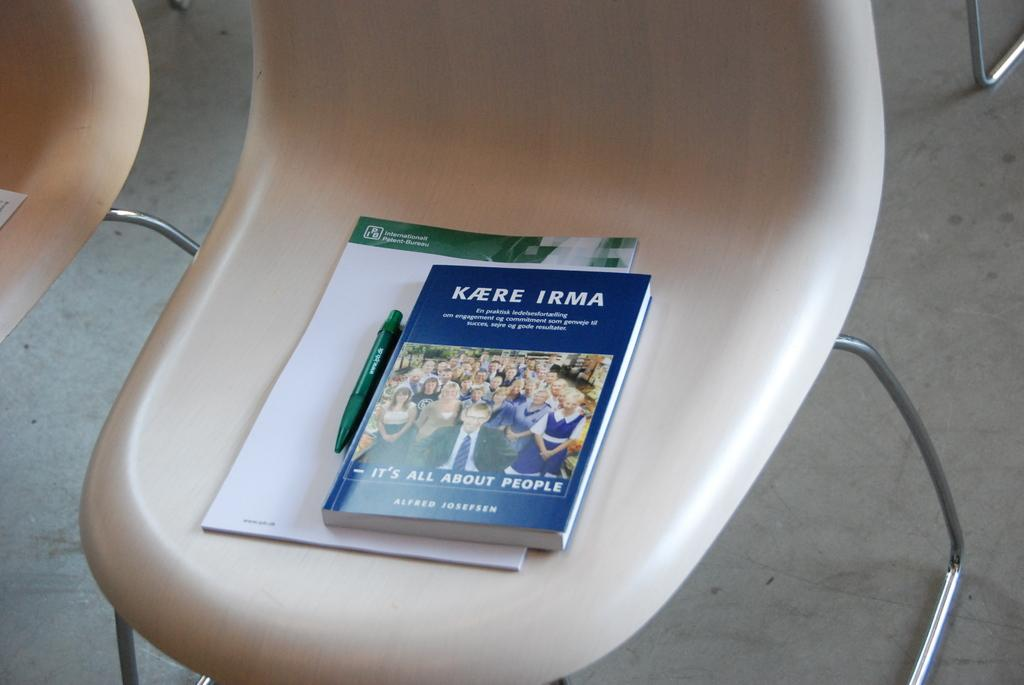Provide a one-sentence caption for the provided image. white plastic chair whit kaere irma booklets and a pen. 